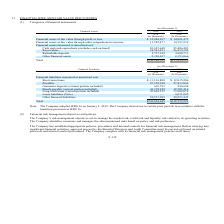According to United Micro Electronics's financial document, When did the company adopt IFRS 16? According to the financial document, January 1, 2019. The relevant text states: "Note: The Company adopted IFRS 16 on January 1, 2019. The Company elected not to restate prior periods in accordance with the transition provision in IF..." Also, What are the company's risk management objectives? to manage the market risk, credit risk and liquidity risk related to its operating activities. The document states: "The Company’s risk management objectives are to manage the market risk, credit risk and liquidity risk related to its operating activities. The Compan..." Also, What were the Financial assets at fair value through profit or loss in 2018? According to the financial document, $12,084,297 (in thousands). The relevant text states: "ial assets at fair value through profit or loss $ 12,084,297 $ 14,021,473 Financial assets at fair value through other comprehensive income 11,585,477 14,723,23..." Also, can you calculate: What is the increase / (decrease) in the Financial assets at fair value through profit or loss from 2018 to 2019? Based on the calculation: 14,021,473 - 12,084,297, the result is 1937176 (in thousands). This is based on the information: "fair value through profit or loss $ 12,084,297 $ 14,021,473 Financial assets at fair value through other comprehensive income 11,585,477 14,723,232 Financial a ial assets at fair value through profit ..." The key data points involved are: 12,084,297, 14,021,473. Also, can you calculate: What is the increase / (decrease) in the Short-term loans from 2018 to 2019? Based on the calculation: 12,015,206 - 13,103,808, the result is -1088602 (in thousands). This is based on the information: "ies measured at amortized cost Short-term loans $ 13,103,808 $ 12,015,206 Payables 23,559,548 27,433,065 Guarantee deposits (current portion included) 665,793 2 at amortized cost Short-term loans $ 13..." The key data points involved are: 12,015,206, 13,103,808. Also, can you calculate: What is the percentage change of Other financial assets from 2018 to 2019? To answer this question, I need to perform calculations using the financial data. The calculation is: 2,353,066 / 2,320,037 - 1, which equals 1.42 (percentage). This is based on the information: "posits 2,757,399 2,600,733 Other financial assets 2,320,037 2,353,066 Total $136,986,309 $155,644,299 57,399 2,600,733 Other financial assets 2,320,037 2,353,066 Total $136,986,309 $155,644,299..." The key data points involved are: 2,320,037, 2,353,066. 